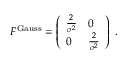Convert formula to latex. <formula><loc_0><loc_0><loc_500><loc_500>\begin{array} { r } { F ^ { G a u s s } = \left ( \begin{array} { l l } { \frac { 2 } { \sigma ^ { 2 } } } & { 0 } \\ { 0 } & { \frac { 2 } { \sigma ^ { 2 } } } \end{array} \right ) \, . } \end{array}</formula> 